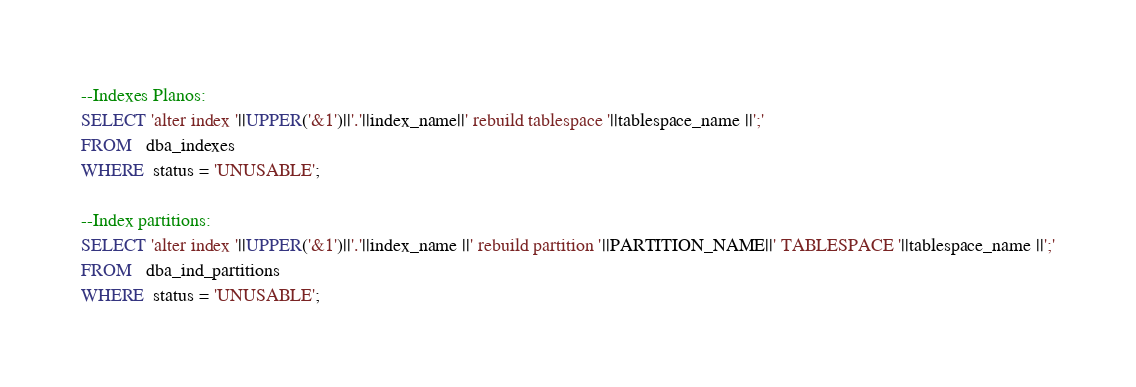Convert code to text. <code><loc_0><loc_0><loc_500><loc_500><_SQL_>--Indexes Planos:
SELECT 'alter index '||UPPER('&1')||'.'||index_name||' rebuild tablespace '||tablespace_name ||';'
FROM   dba_indexes
WHERE  status = 'UNUSABLE';

--Index partitions:
SELECT 'alter index '||UPPER('&1')||'.'||index_name ||' rebuild partition '||PARTITION_NAME||' TABLESPACE '||tablespace_name ||';'
FROM   dba_ind_partitions
WHERE  status = 'UNUSABLE';

</code> 